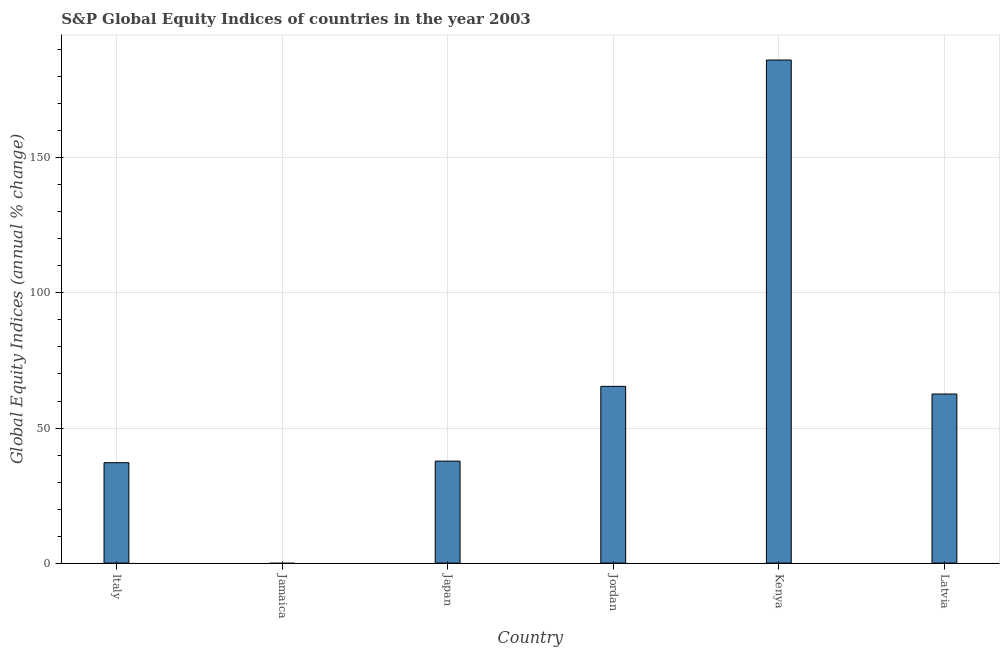Does the graph contain any zero values?
Your response must be concise. Yes. Does the graph contain grids?
Your answer should be very brief. Yes. What is the title of the graph?
Provide a short and direct response. S&P Global Equity Indices of countries in the year 2003. What is the label or title of the Y-axis?
Your response must be concise. Global Equity Indices (annual % change). What is the s&p global equity indices in Jamaica?
Keep it short and to the point. 0. Across all countries, what is the maximum s&p global equity indices?
Your answer should be compact. 186.21. In which country was the s&p global equity indices maximum?
Your answer should be compact. Kenya. What is the sum of the s&p global equity indices?
Ensure brevity in your answer.  389.13. What is the difference between the s&p global equity indices in Italy and Jordan?
Offer a terse response. -28.25. What is the average s&p global equity indices per country?
Make the answer very short. 64.85. What is the median s&p global equity indices?
Give a very brief answer. 50.17. What is the ratio of the s&p global equity indices in Italy to that in Jordan?
Provide a succinct answer. 0.57. Is the difference between the s&p global equity indices in Kenya and Latvia greater than the difference between any two countries?
Offer a terse response. No. What is the difference between the highest and the second highest s&p global equity indices?
Your response must be concise. 120.79. Is the sum of the s&p global equity indices in Italy and Kenya greater than the maximum s&p global equity indices across all countries?
Provide a succinct answer. Yes. What is the difference between the highest and the lowest s&p global equity indices?
Ensure brevity in your answer.  186.21. In how many countries, is the s&p global equity indices greater than the average s&p global equity indices taken over all countries?
Offer a terse response. 2. Are all the bars in the graph horizontal?
Provide a short and direct response. No. Are the values on the major ticks of Y-axis written in scientific E-notation?
Make the answer very short. No. What is the Global Equity Indices (annual % change) in Italy?
Give a very brief answer. 37.17. What is the Global Equity Indices (annual % change) of Japan?
Your answer should be compact. 37.74. What is the Global Equity Indices (annual % change) in Jordan?
Your answer should be compact. 65.42. What is the Global Equity Indices (annual % change) in Kenya?
Make the answer very short. 186.21. What is the Global Equity Indices (annual % change) of Latvia?
Offer a very short reply. 62.59. What is the difference between the Global Equity Indices (annual % change) in Italy and Japan?
Give a very brief answer. -0.58. What is the difference between the Global Equity Indices (annual % change) in Italy and Jordan?
Give a very brief answer. -28.25. What is the difference between the Global Equity Indices (annual % change) in Italy and Kenya?
Offer a very short reply. -149.04. What is the difference between the Global Equity Indices (annual % change) in Italy and Latvia?
Your answer should be compact. -25.42. What is the difference between the Global Equity Indices (annual % change) in Japan and Jordan?
Your response must be concise. -27.68. What is the difference between the Global Equity Indices (annual % change) in Japan and Kenya?
Your answer should be compact. -148.47. What is the difference between the Global Equity Indices (annual % change) in Japan and Latvia?
Your answer should be compact. -24.85. What is the difference between the Global Equity Indices (annual % change) in Jordan and Kenya?
Give a very brief answer. -120.79. What is the difference between the Global Equity Indices (annual % change) in Jordan and Latvia?
Your answer should be very brief. 2.83. What is the difference between the Global Equity Indices (annual % change) in Kenya and Latvia?
Your answer should be very brief. 123.62. What is the ratio of the Global Equity Indices (annual % change) in Italy to that in Jordan?
Your answer should be compact. 0.57. What is the ratio of the Global Equity Indices (annual % change) in Italy to that in Kenya?
Give a very brief answer. 0.2. What is the ratio of the Global Equity Indices (annual % change) in Italy to that in Latvia?
Offer a terse response. 0.59. What is the ratio of the Global Equity Indices (annual % change) in Japan to that in Jordan?
Offer a very short reply. 0.58. What is the ratio of the Global Equity Indices (annual % change) in Japan to that in Kenya?
Offer a very short reply. 0.2. What is the ratio of the Global Equity Indices (annual % change) in Japan to that in Latvia?
Keep it short and to the point. 0.6. What is the ratio of the Global Equity Indices (annual % change) in Jordan to that in Kenya?
Provide a succinct answer. 0.35. What is the ratio of the Global Equity Indices (annual % change) in Jordan to that in Latvia?
Give a very brief answer. 1.04. What is the ratio of the Global Equity Indices (annual % change) in Kenya to that in Latvia?
Provide a succinct answer. 2.98. 